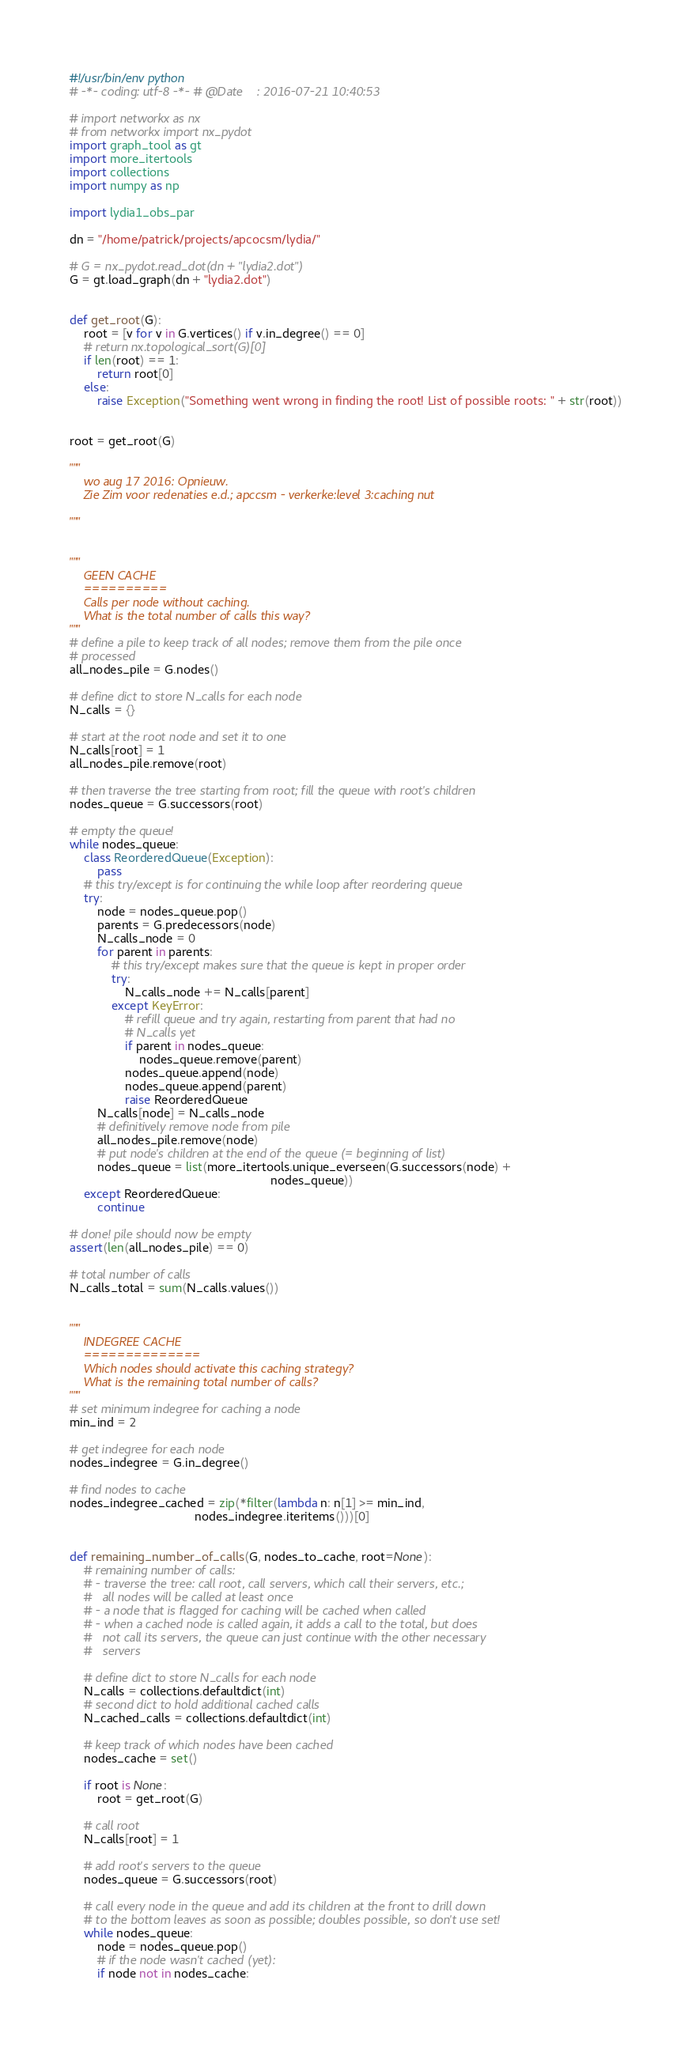Convert code to text. <code><loc_0><loc_0><loc_500><loc_500><_Python_>#!/usr/bin/env python
# -*- coding: utf-8 -*- # @Date    : 2016-07-21 10:40:53

# import networkx as nx
# from networkx import nx_pydot
import graph_tool as gt
import more_itertools
import collections
import numpy as np

import lydia1_obs_par

dn = "/home/patrick/projects/apcocsm/lydia/"

# G = nx_pydot.read_dot(dn + "lydia2.dot")
G = gt.load_graph(dn + "lydia2.dot")


def get_root(G):
    root = [v for v in G.vertices() if v.in_degree() == 0]
    # return nx.topological_sort(G)[0]
    if len(root) == 1:
        return root[0]
    else:
        raise Exception("Something went wrong in finding the root! List of possible roots: " + str(root))


root = get_root(G)

"""
    wo aug 17 2016: Opnieuw.
    Zie Zim voor redenaties e.d.; apccsm - verkerke:level 3:caching nut

"""


"""
    GEEN CACHE
    ==========
    Calls per node without caching.
    What is the total number of calls this way?
"""
# define a pile to keep track of all nodes; remove them from the pile once
# processed
all_nodes_pile = G.nodes()

# define dict to store N_calls for each node
N_calls = {}

# start at the root node and set it to one
N_calls[root] = 1
all_nodes_pile.remove(root)

# then traverse the tree starting from root; fill the queue with root's children
nodes_queue = G.successors(root)

# empty the queue!
while nodes_queue:
    class ReorderedQueue(Exception):
        pass
    # this try/except is for continuing the while loop after reordering queue
    try:
        node = nodes_queue.pop()
        parents = G.predecessors(node)
        N_calls_node = 0
        for parent in parents:
            # this try/except makes sure that the queue is kept in proper order
            try:
                N_calls_node += N_calls[parent]
            except KeyError:
                # refill queue and try again, restarting from parent that had no
                # N_calls yet
                if parent in nodes_queue:
                    nodes_queue.remove(parent)
                nodes_queue.append(node)
                nodes_queue.append(parent)
                raise ReorderedQueue
        N_calls[node] = N_calls_node
        # definitively remove node from pile
        all_nodes_pile.remove(node)
        # put node's children at the end of the queue (= beginning of list)
        nodes_queue = list(more_itertools.unique_everseen(G.successors(node) +
                                                          nodes_queue))
    except ReorderedQueue:
        continue

# done! pile should now be empty
assert(len(all_nodes_pile) == 0)

# total number of calls
N_calls_total = sum(N_calls.values())


"""
    INDEGREE CACHE
    ==============
    Which nodes should activate this caching strategy?
    What is the remaining total number of calls?
"""
# set minimum indegree for caching a node
min_ind = 2

# get indegree for each node
nodes_indegree = G.in_degree()

# find nodes to cache
nodes_indegree_cached = zip(*filter(lambda n: n[1] >= min_ind,
                                    nodes_indegree.iteritems()))[0]


def remaining_number_of_calls(G, nodes_to_cache, root=None):
    # remaining number of calls:
    # - traverse the tree: call root, call servers, which call their servers, etc.;
    #   all nodes will be called at least once
    # - a node that is flagged for caching will be cached when called
    # - when a cached node is called again, it adds a call to the total, but does
    #   not call its servers, the queue can just continue with the other necessary
    #   servers

    # define dict to store N_calls for each node
    N_calls = collections.defaultdict(int)
    # second dict to hold additional cached calls
    N_cached_calls = collections.defaultdict(int)

    # keep track of which nodes have been cached
    nodes_cache = set()

    if root is None:
        root = get_root(G)

    # call root
    N_calls[root] = 1

    # add root's servers to the queue
    nodes_queue = G.successors(root)

    # call every node in the queue and add its children at the front to drill down
    # to the bottom leaves as soon as possible; doubles possible, so don't use set!
    while nodes_queue:
        node = nodes_queue.pop()
        # if the node wasn't cached (yet):
        if node not in nodes_cache:</code> 